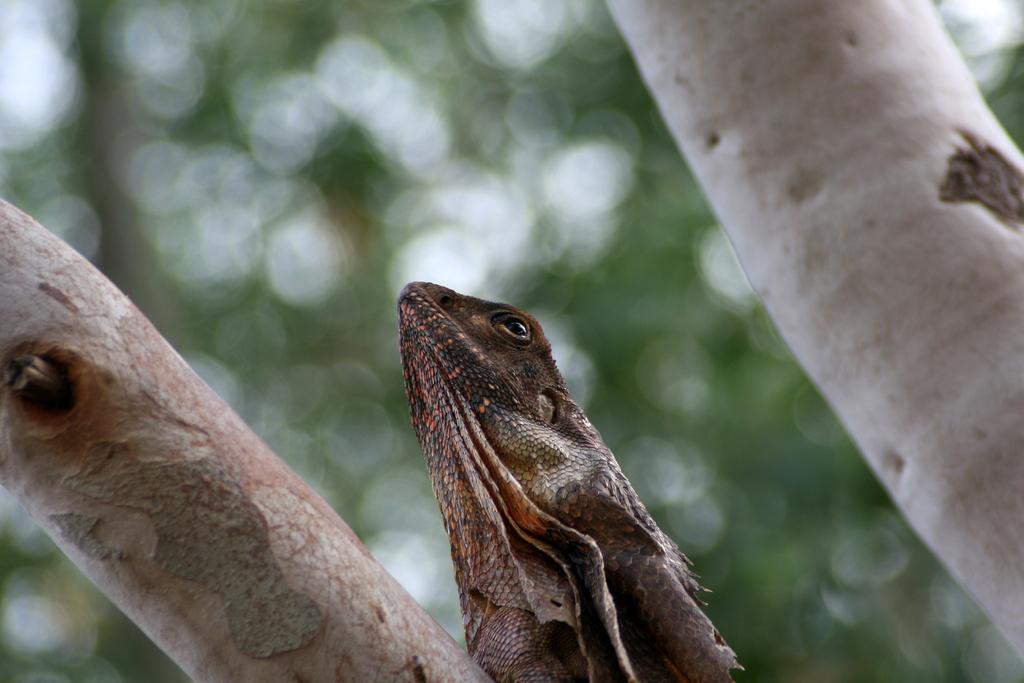What type of natural elements are present in the image? The image contains tree trunks. Is there any wildlife visible in the image? Yes, there is an animal on one of the tree trunks. Can you describe the background of the image? The background of the image is blurred. What type of curtain can be seen hanging from the tree trunks in the image? There is no curtain present in the image; it features tree trunks and an animal. 